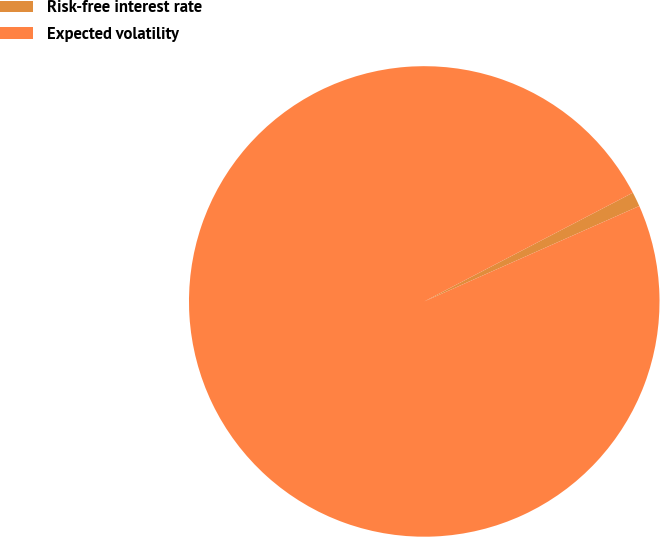<chart> <loc_0><loc_0><loc_500><loc_500><pie_chart><fcel>Risk-free interest rate<fcel>Expected volatility<nl><fcel>1.0%<fcel>99.0%<nl></chart> 